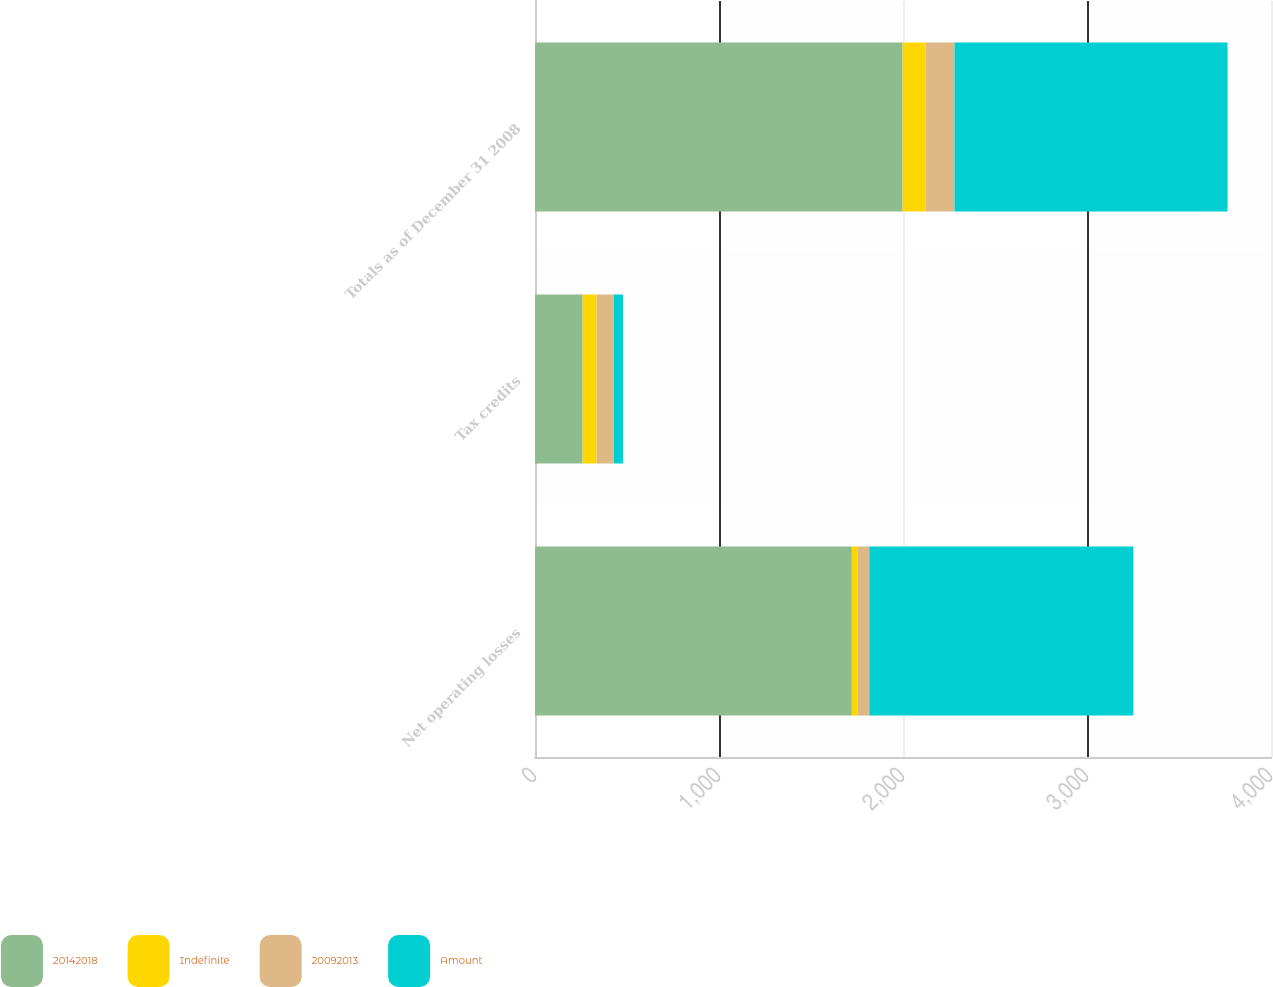<chart> <loc_0><loc_0><loc_500><loc_500><stacked_bar_chart><ecel><fcel>Net operating losses<fcel>Tax credits<fcel>Totals as of December 31 2008<nl><fcel>20142018<fcel>1722<fcel>259<fcel>1998<nl><fcel>Indefinite<fcel>33<fcel>76<fcel>126<nl><fcel>20092013<fcel>62<fcel>94<fcel>156<nl><fcel>Amount<fcel>1435<fcel>49<fcel>1484<nl></chart> 